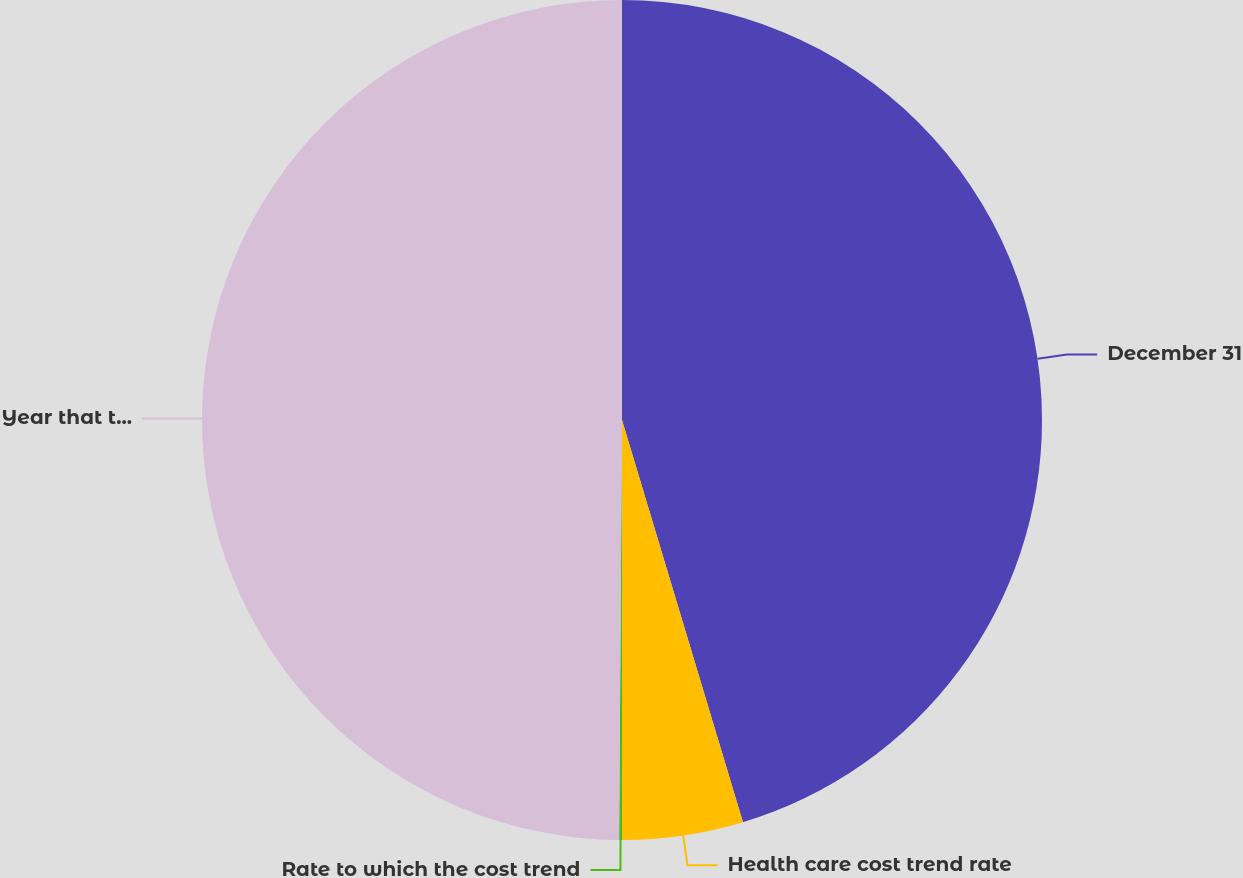Convert chart. <chart><loc_0><loc_0><loc_500><loc_500><pie_chart><fcel>December 31<fcel>Health care cost trend rate<fcel>Rate to which the cost trend<fcel>Year that the trend rate<nl><fcel>45.35%<fcel>4.65%<fcel>0.11%<fcel>49.89%<nl></chart> 